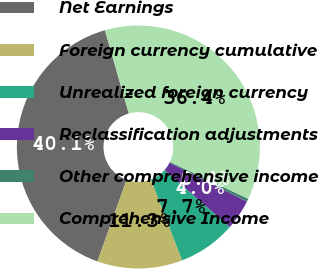Convert chart. <chart><loc_0><loc_0><loc_500><loc_500><pie_chart><fcel>Net Earnings<fcel>Foreign currency cumulative<fcel>Unrealized foreign currency<fcel>Reclassification adjustments<fcel>Other comprehensive income<fcel>Comprehensive Income<nl><fcel>40.09%<fcel>11.33%<fcel>7.69%<fcel>4.04%<fcel>0.4%<fcel>36.44%<nl></chart> 